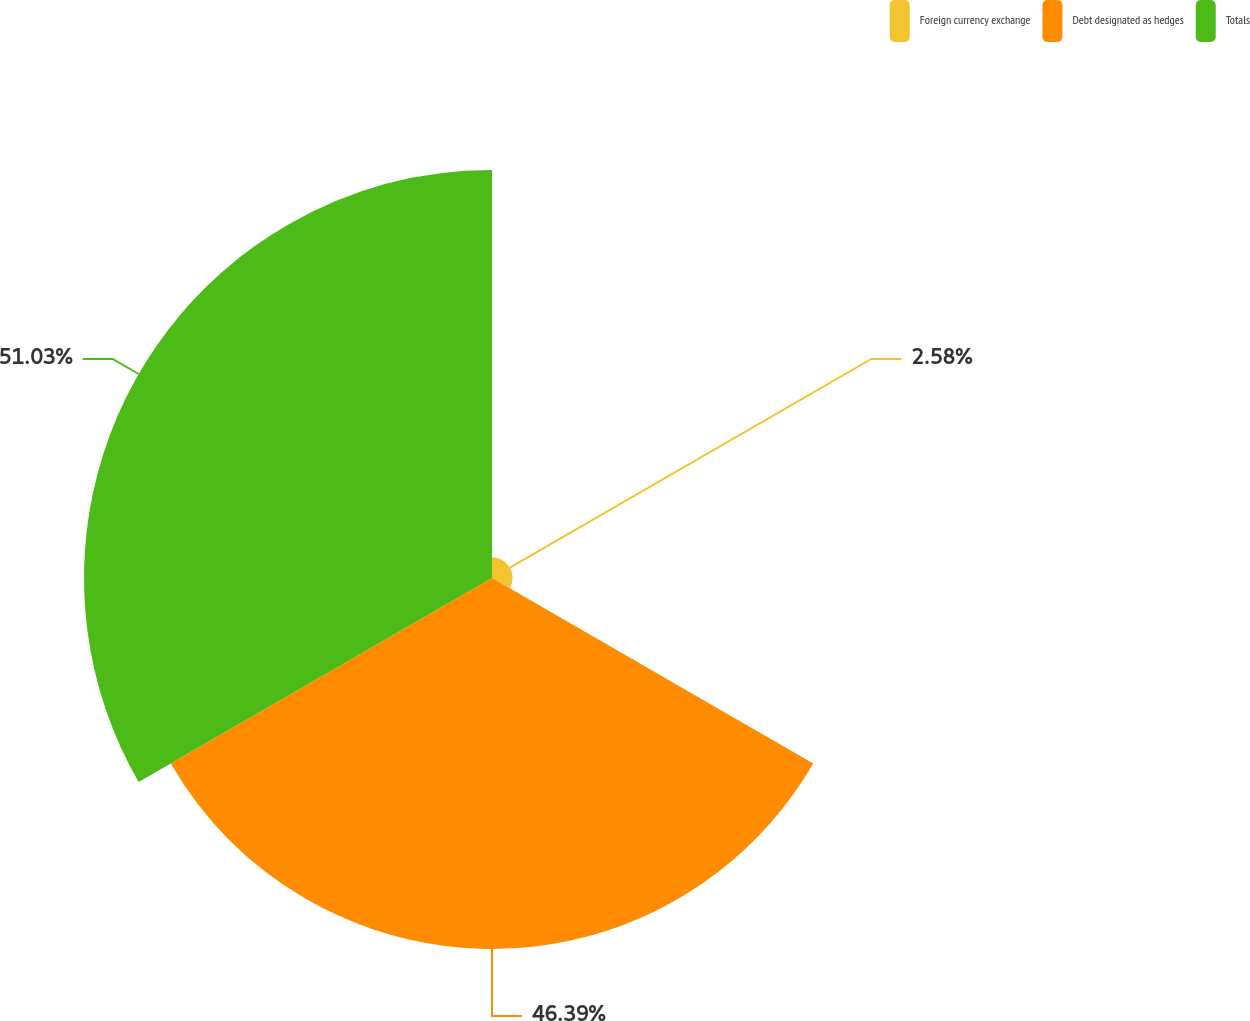<chart> <loc_0><loc_0><loc_500><loc_500><pie_chart><fcel>Foreign currency exchange<fcel>Debt designated as hedges<fcel>Totals<nl><fcel>2.58%<fcel>46.39%<fcel>51.03%<nl></chart> 